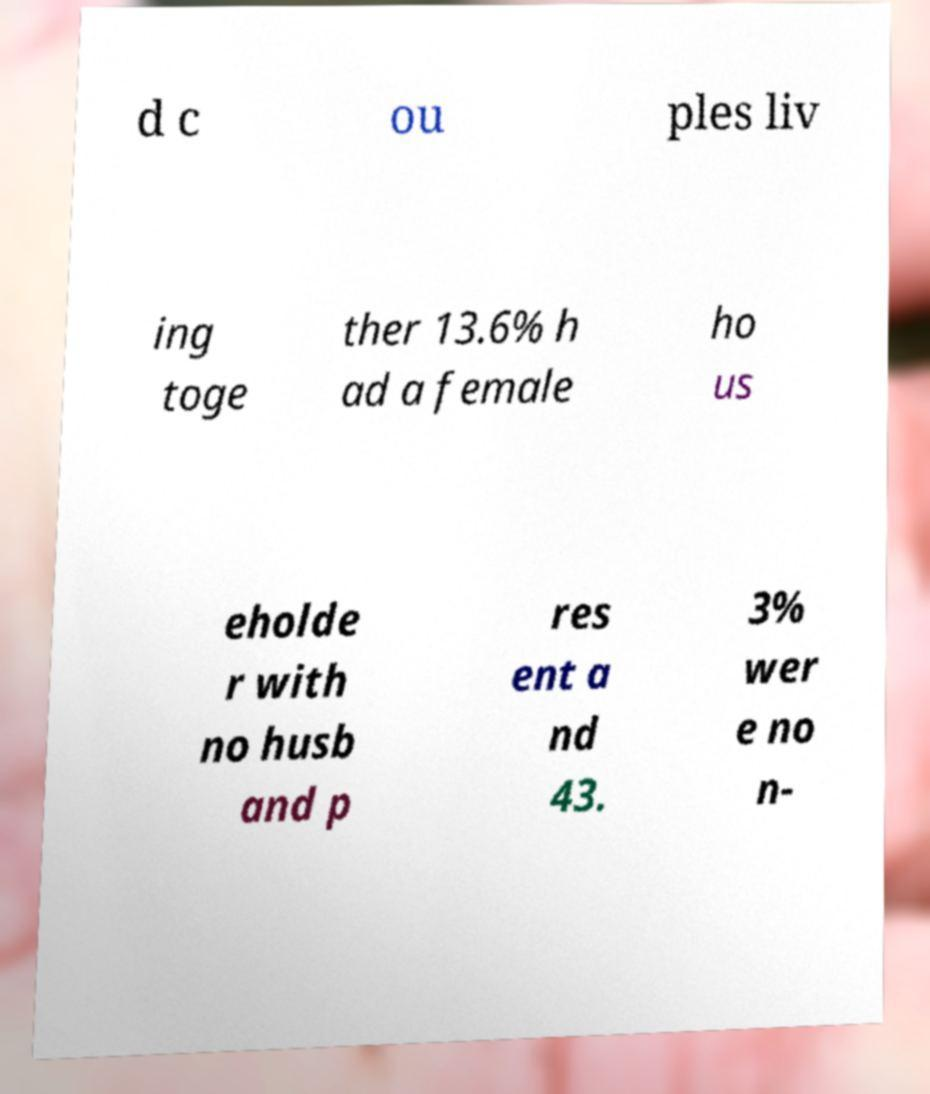Could you assist in decoding the text presented in this image and type it out clearly? d c ou ples liv ing toge ther 13.6% h ad a female ho us eholde r with no husb and p res ent a nd 43. 3% wer e no n- 